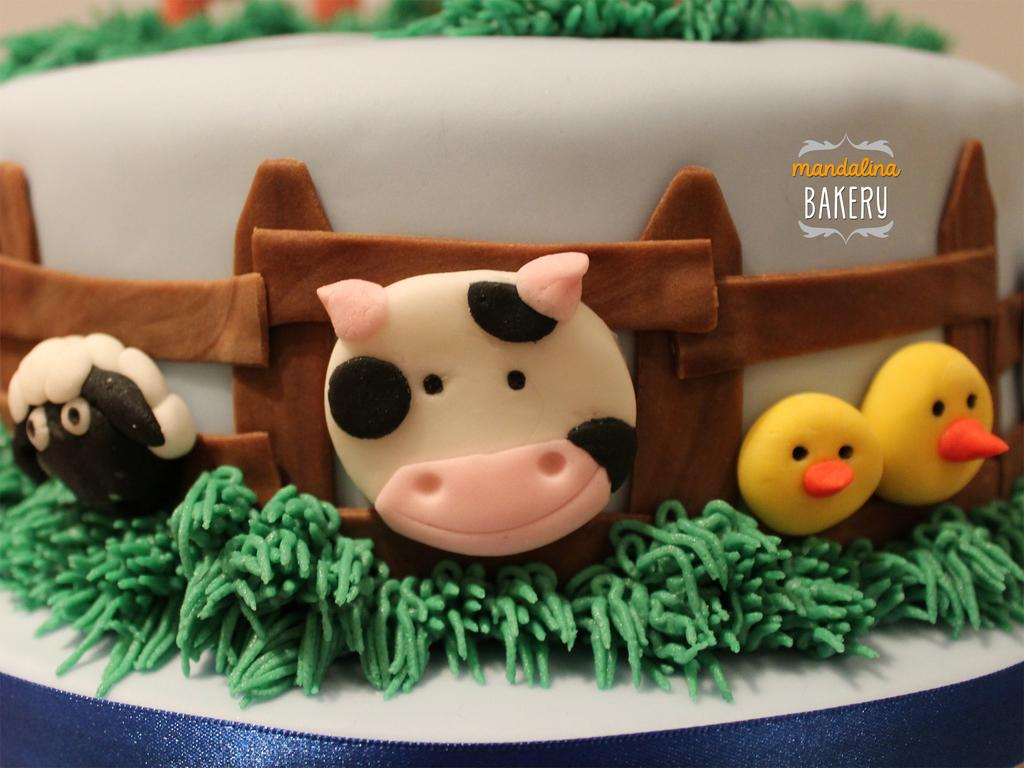What is the main subject of the image? The main subject of the image is a cake. Can you describe any specific features of the cake? Yes, the cake has cream on it. Where can the lettuce be found in the image? There is no lettuce present in the image. What type of government is depicted in the image? There is no government depicted in the image; it features a cake with cream on it. 